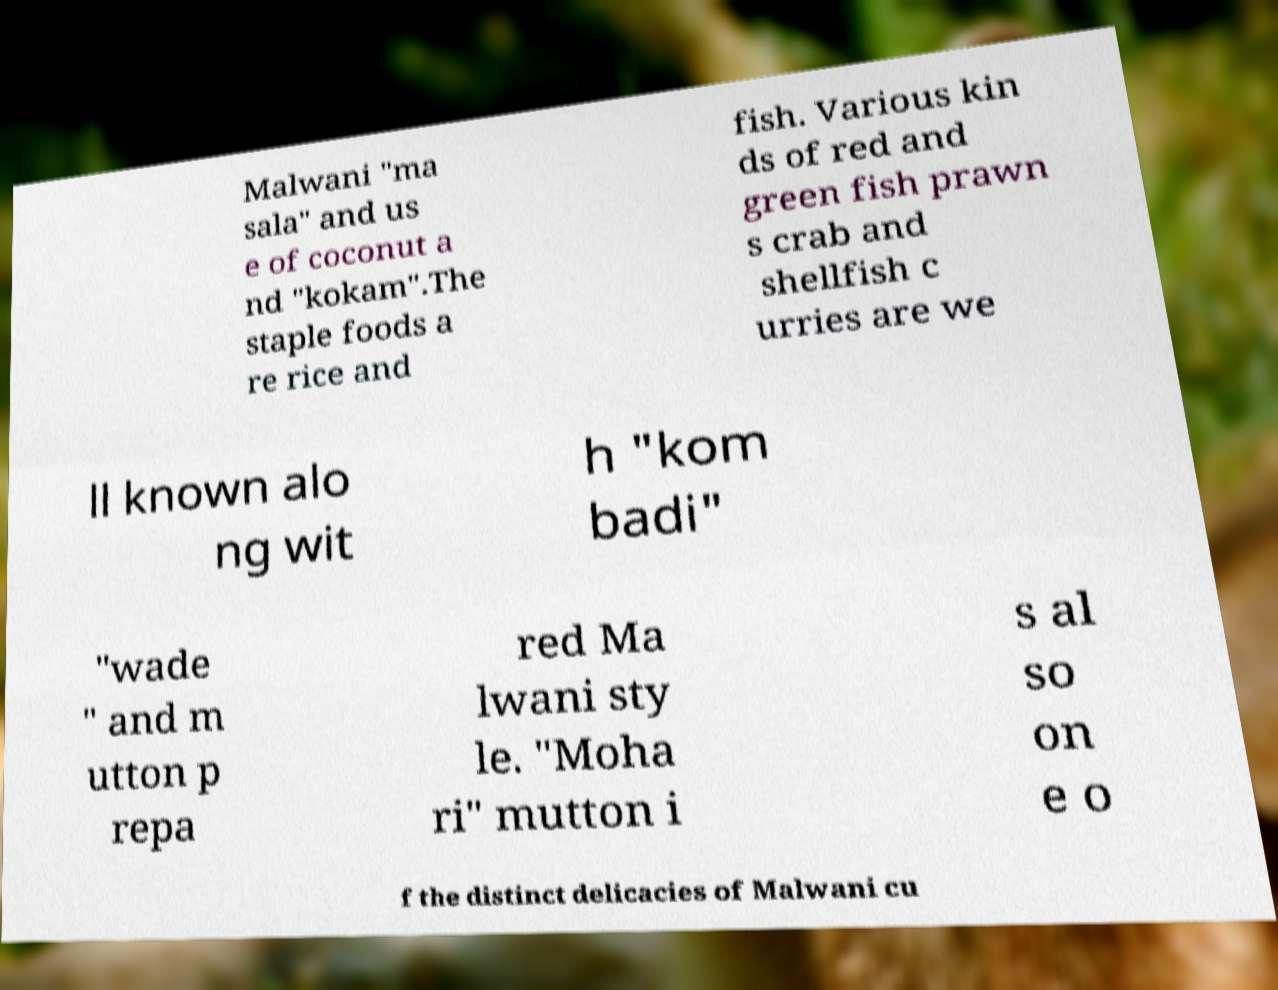Can you read and provide the text displayed in the image?This photo seems to have some interesting text. Can you extract and type it out for me? Malwani "ma sala" and us e of coconut a nd "kokam".The staple foods a re rice and fish. Various kin ds of red and green fish prawn s crab and shellfish c urries are we ll known alo ng wit h "kom badi" "wade " and m utton p repa red Ma lwani sty le. "Moha ri" mutton i s al so on e o f the distinct delicacies of Malwani cu 